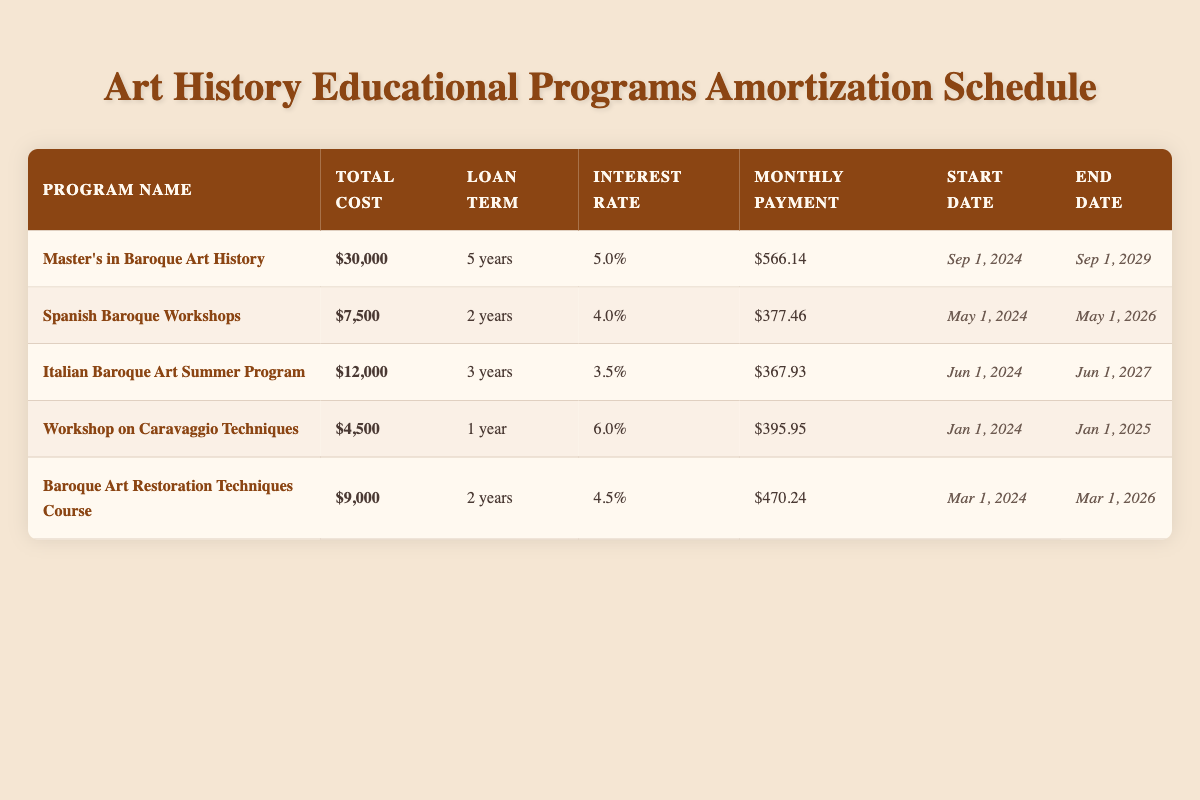What is the total cost of the Master's in Baroque Art History? The table clearly shows that the total cost for the Master's in Baroque Art History is listed as $30,000.
Answer: $30,000 What is the monthly payment for the Spanish Baroque Workshops? The table indicates that the monthly payment for the Spanish Baroque Workshops is $377.46.
Answer: $377.46 How many years does the Italian Baroque Art Summer Program last? The duration for the Italian Baroque Art Summer Program is provided in the table as 3 years.
Answer: 3 years Is the interest rate for the Workshop on Caravaggio Techniques higher than 5%? The interest rate for the Workshop on Caravaggio Techniques is 6.0%, which is indeed higher than 5%.
Answer: Yes Which program has the highest monthly payment? To find this, we compare the monthly payments listed: the highest amount is $566.14 for the Master's in Baroque Art History.
Answer: Master's in Baroque Art History What is the average monthly payment for all programs? The monthly payments are: $566.14, $377.46, $367.93, $395.95, $470.24. Summing these gives $2,177.72. Dividing by 5 programs yields an average of $435.54.
Answer: $435.54 Which program ends the earliest and on what date? The program that ends the earliest is the Workshop on Caravaggio Techniques, with an end date of January 1, 2025.
Answer: Workshop on Caravaggio Techniques, January 1, 2025 How much more is the total cost of the Master's in Baroque Art History compared to the Workshop on Caravaggio Techniques? The total cost for the Master's in Baroque Art History is $30,000, while the Workshop on Caravaggio Techniques costs $4,500. The difference is $30,000 - $4,500 = $25,500.
Answer: $25,500 What are the total costs of the Baroque Art Restoration Techniques Course and the Spanish Baroque Workshops combined? The total cost of the Baroque Art Restoration Techniques Course is $9,000 and the Spanish Baroque Workshops is $7,500. Adding these amounts gives $9,000 + $7,500 = $16,500.
Answer: $16,500 